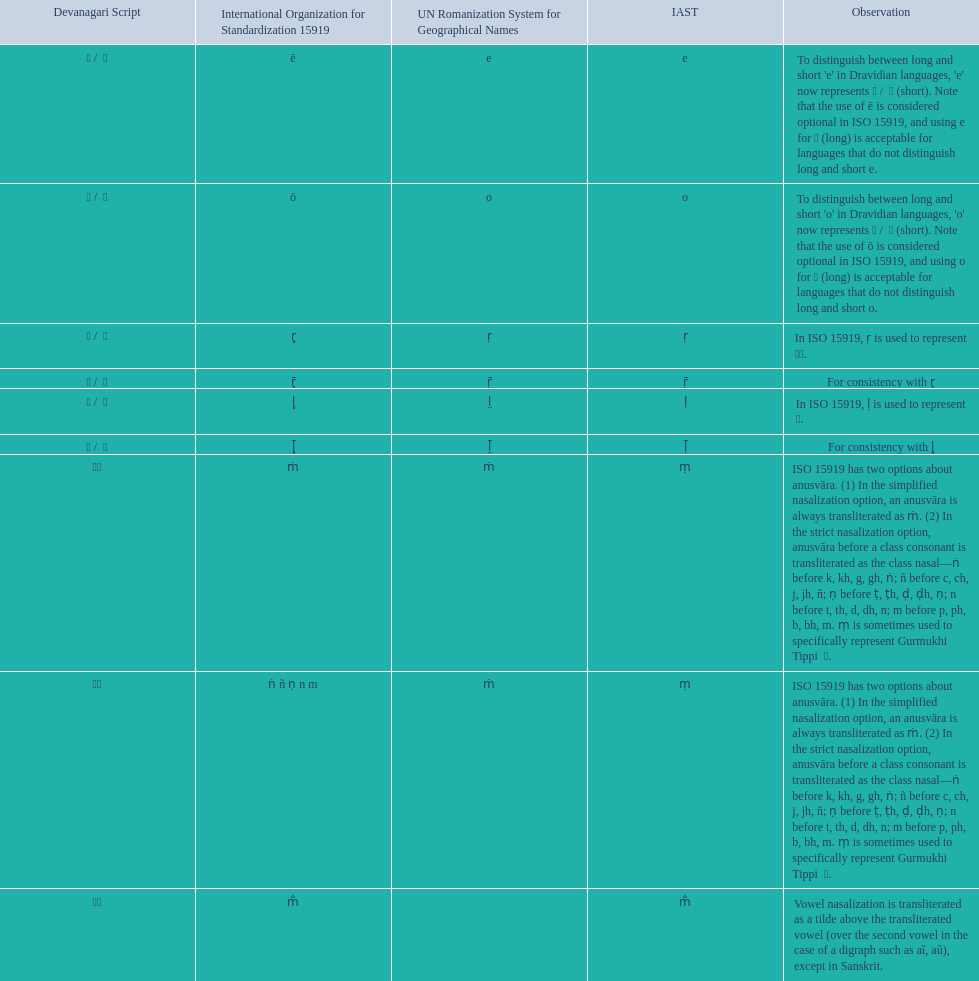How many total options are there about anusvara? 2. 